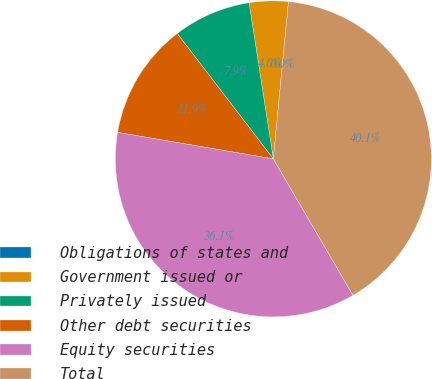Convert chart to OTSL. <chart><loc_0><loc_0><loc_500><loc_500><pie_chart><fcel>Obligations of states and<fcel>Government issued or<fcel>Privately issued<fcel>Other debt securities<fcel>Equity securities<fcel>Total<nl><fcel>0.01%<fcel>3.98%<fcel>7.95%<fcel>11.91%<fcel>36.09%<fcel>40.06%<nl></chart> 